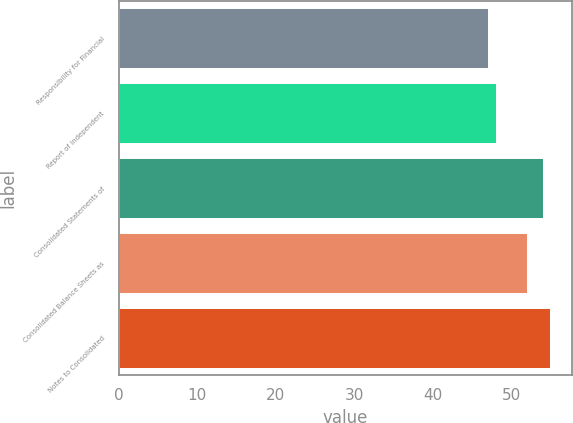Convert chart. <chart><loc_0><loc_0><loc_500><loc_500><bar_chart><fcel>Responsibility for Financial<fcel>Report of Independent<fcel>Consolidated Statements of<fcel>Consolidated Balance Sheets as<fcel>Notes to Consolidated<nl><fcel>47<fcel>48<fcel>54<fcel>52<fcel>55<nl></chart> 